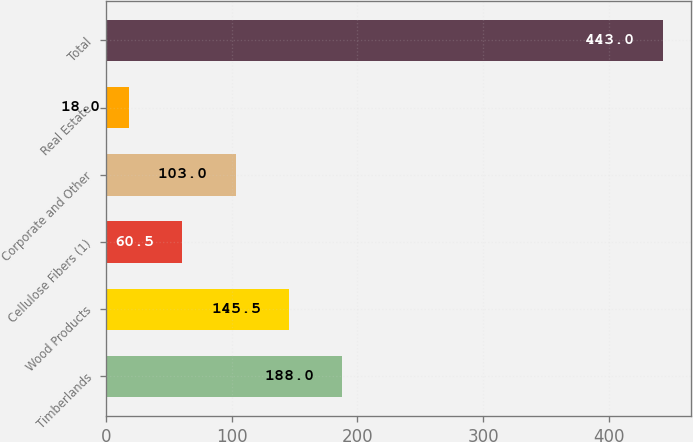Convert chart to OTSL. <chart><loc_0><loc_0><loc_500><loc_500><bar_chart><fcel>Timberlands<fcel>Wood Products<fcel>Cellulose Fibers (1)<fcel>Corporate and Other<fcel>Real Estate<fcel>Total<nl><fcel>188<fcel>145.5<fcel>60.5<fcel>103<fcel>18<fcel>443<nl></chart> 